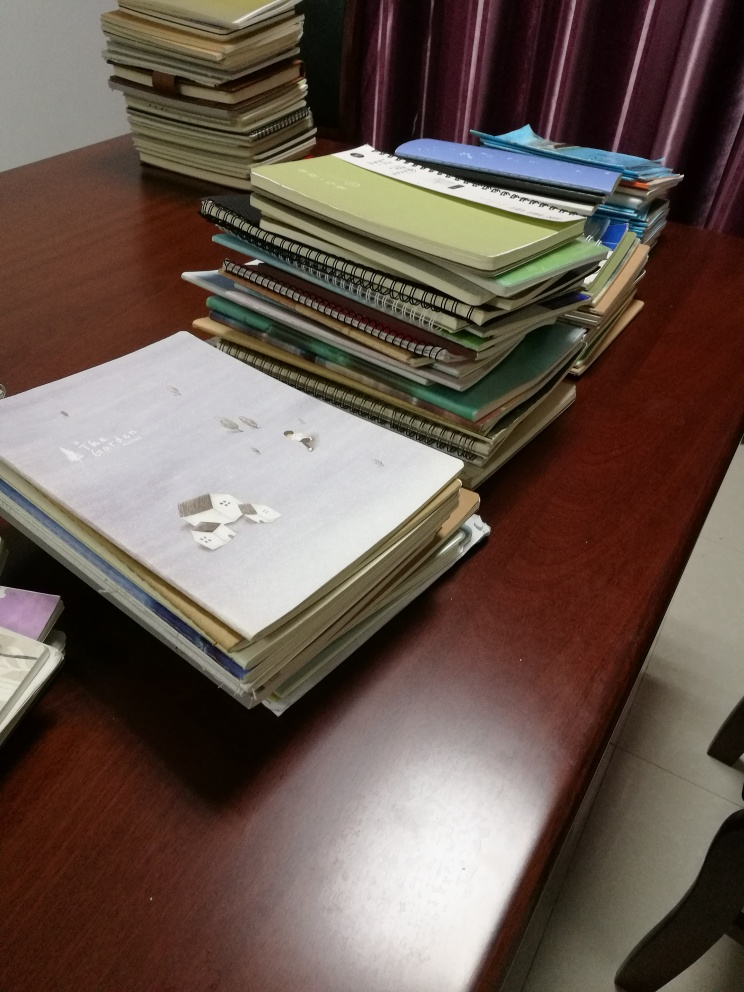Is there any blurriness in the image? Upon closer examination, the image appears to be quite sharp, with no discernible blurriness affecting the clarity of the objects within the scene. The stacks of books and papers, as well as the items on the desk, show clear edges and fine details, indicating a high-quality image capture. 